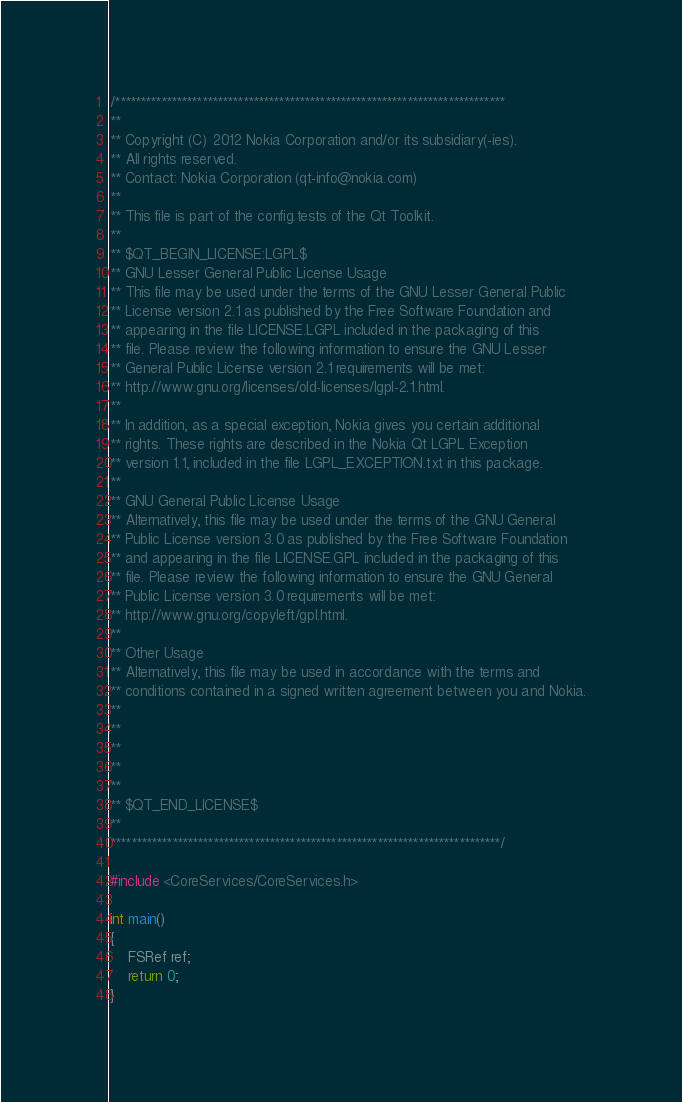<code> <loc_0><loc_0><loc_500><loc_500><_ObjectiveC_>/****************************************************************************
**
** Copyright (C) 2012 Nokia Corporation and/or its subsidiary(-ies).
** All rights reserved.
** Contact: Nokia Corporation (qt-info@nokia.com)
**
** This file is part of the config.tests of the Qt Toolkit.
**
** $QT_BEGIN_LICENSE:LGPL$
** GNU Lesser General Public License Usage
** This file may be used under the terms of the GNU Lesser General Public
** License version 2.1 as published by the Free Software Foundation and
** appearing in the file LICENSE.LGPL included in the packaging of this
** file. Please review the following information to ensure the GNU Lesser
** General Public License version 2.1 requirements will be met:
** http://www.gnu.org/licenses/old-licenses/lgpl-2.1.html.
**
** In addition, as a special exception, Nokia gives you certain additional
** rights. These rights are described in the Nokia Qt LGPL Exception
** version 1.1, included in the file LGPL_EXCEPTION.txt in this package.
**
** GNU General Public License Usage
** Alternatively, this file may be used under the terms of the GNU General
** Public License version 3.0 as published by the Free Software Foundation
** and appearing in the file LICENSE.GPL included in the packaging of this
** file. Please review the following information to ensure the GNU General
** Public License version 3.0 requirements will be met:
** http://www.gnu.org/copyleft/gpl.html.
**
** Other Usage
** Alternatively, this file may be used in accordance with the terms and
** conditions contained in a signed written agreement between you and Nokia.
**
**
**
**
**
** $QT_END_LICENSE$
**
****************************************************************************/

#include <CoreServices/CoreServices.h>

int main()
{
    FSRef ref;
    return 0;
}
</code> 